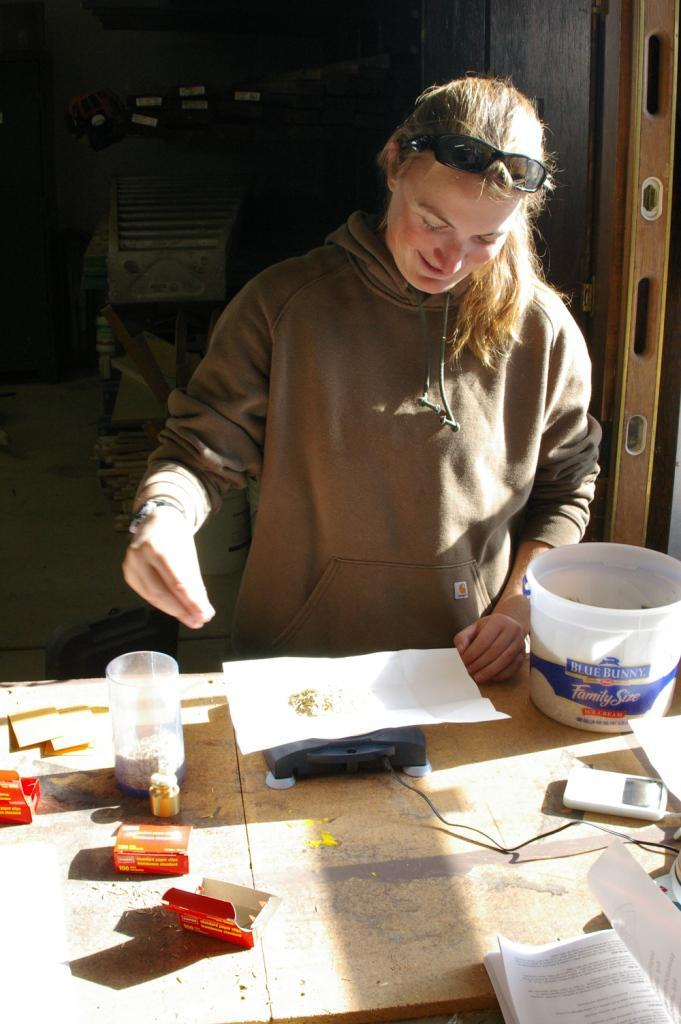What is the person near in the image? The person is standing near a table. What is the person doing near the table? The person is doing something, but the specific action cannot be determined from the facts. What items are on the table in the image? There is a paper, a book, cardboard boxes, and a glass on the table. What type of lumber is stacked in the corner of the room in the image? There is no mention of lumber or any corner in the room in the provided facts, so it cannot be determined from the image. 